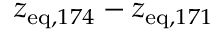Convert formula to latex. <formula><loc_0><loc_0><loc_500><loc_500>z _ { e q , 1 7 4 } - z _ { e q , 1 7 1 }</formula> 